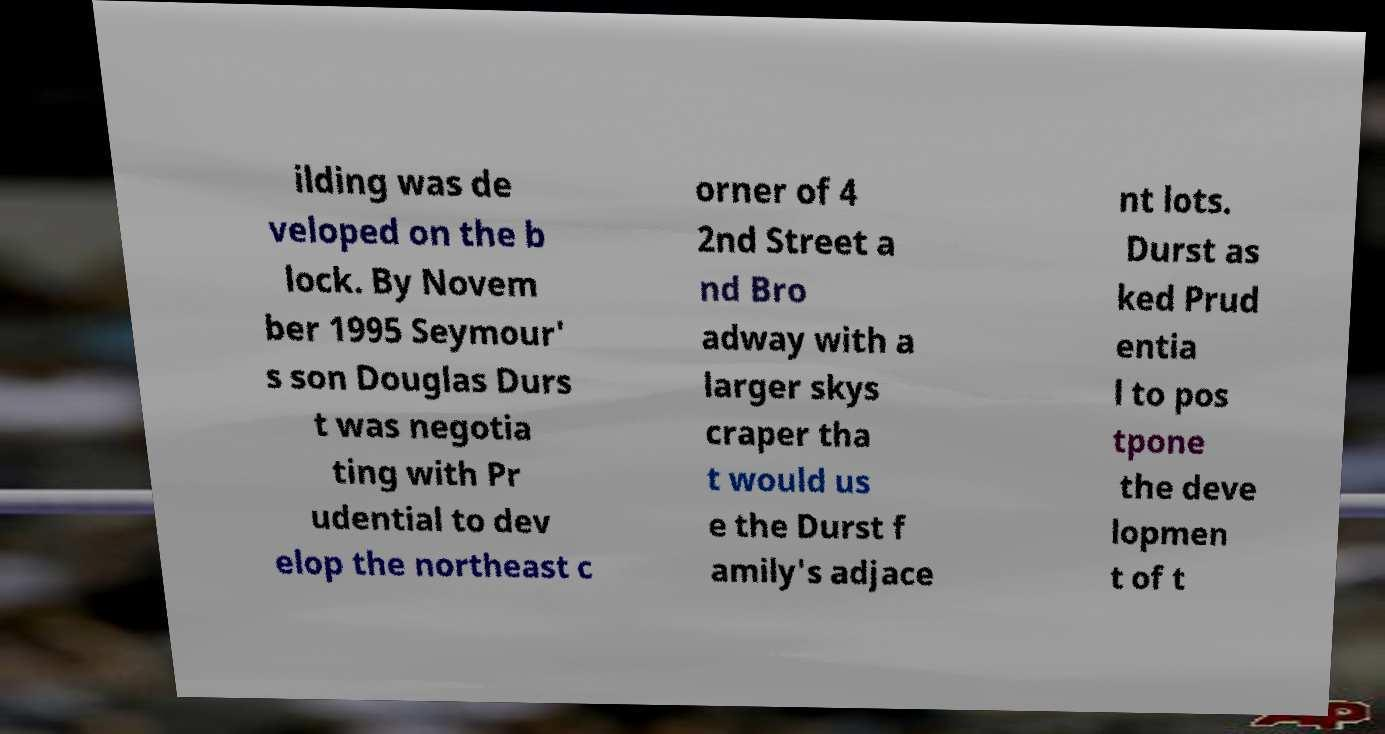I need the written content from this picture converted into text. Can you do that? ilding was de veloped on the b lock. By Novem ber 1995 Seymour' s son Douglas Durs t was negotia ting with Pr udential to dev elop the northeast c orner of 4 2nd Street a nd Bro adway with a larger skys craper tha t would us e the Durst f amily's adjace nt lots. Durst as ked Prud entia l to pos tpone the deve lopmen t of t 